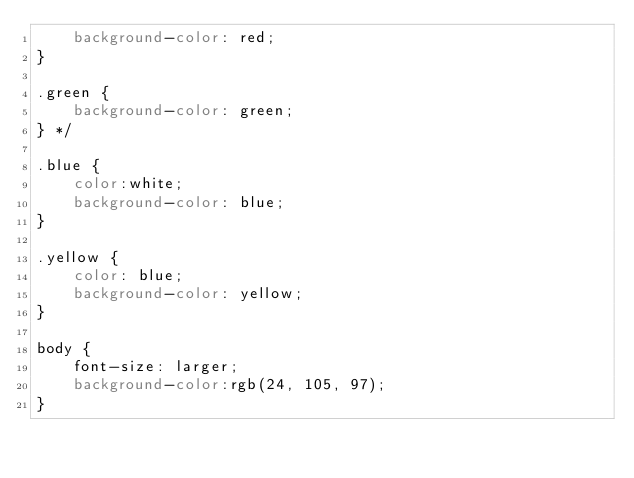<code> <loc_0><loc_0><loc_500><loc_500><_CSS_>    background-color: red;
}  

.green {
    background-color: green;
} */

.blue {
    color:white;
    background-color: blue;
}

.yellow {
    color: blue;
    background-color: yellow;
}

body {
    font-size: larger;
    background-color:rgb(24, 105, 97);
}
</code> 